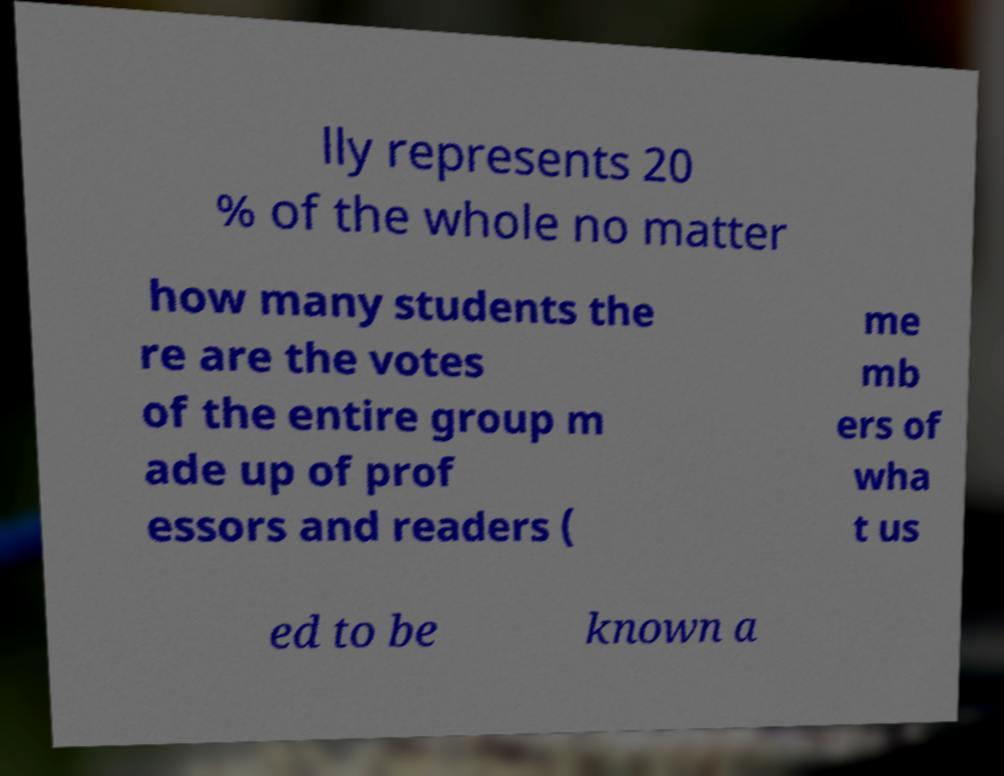There's text embedded in this image that I need extracted. Can you transcribe it verbatim? lly represents 20 % of the whole no matter how many students the re are the votes of the entire group m ade up of prof essors and readers ( me mb ers of wha t us ed to be known a 